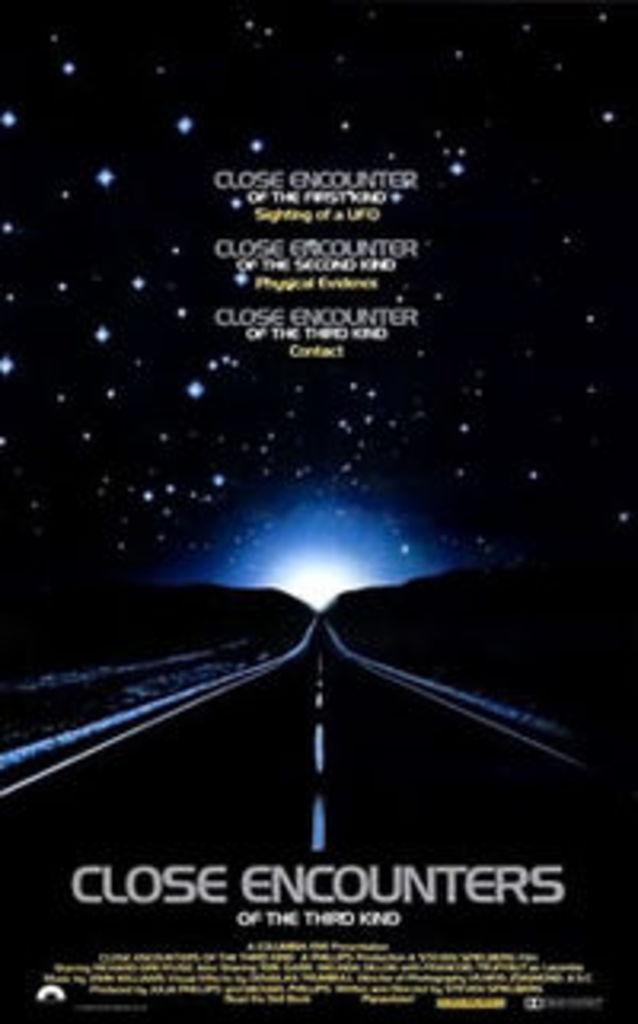<image>
Relay a brief, clear account of the picture shown. A movie poster for the Close Encounters of the Third Kind movie. 